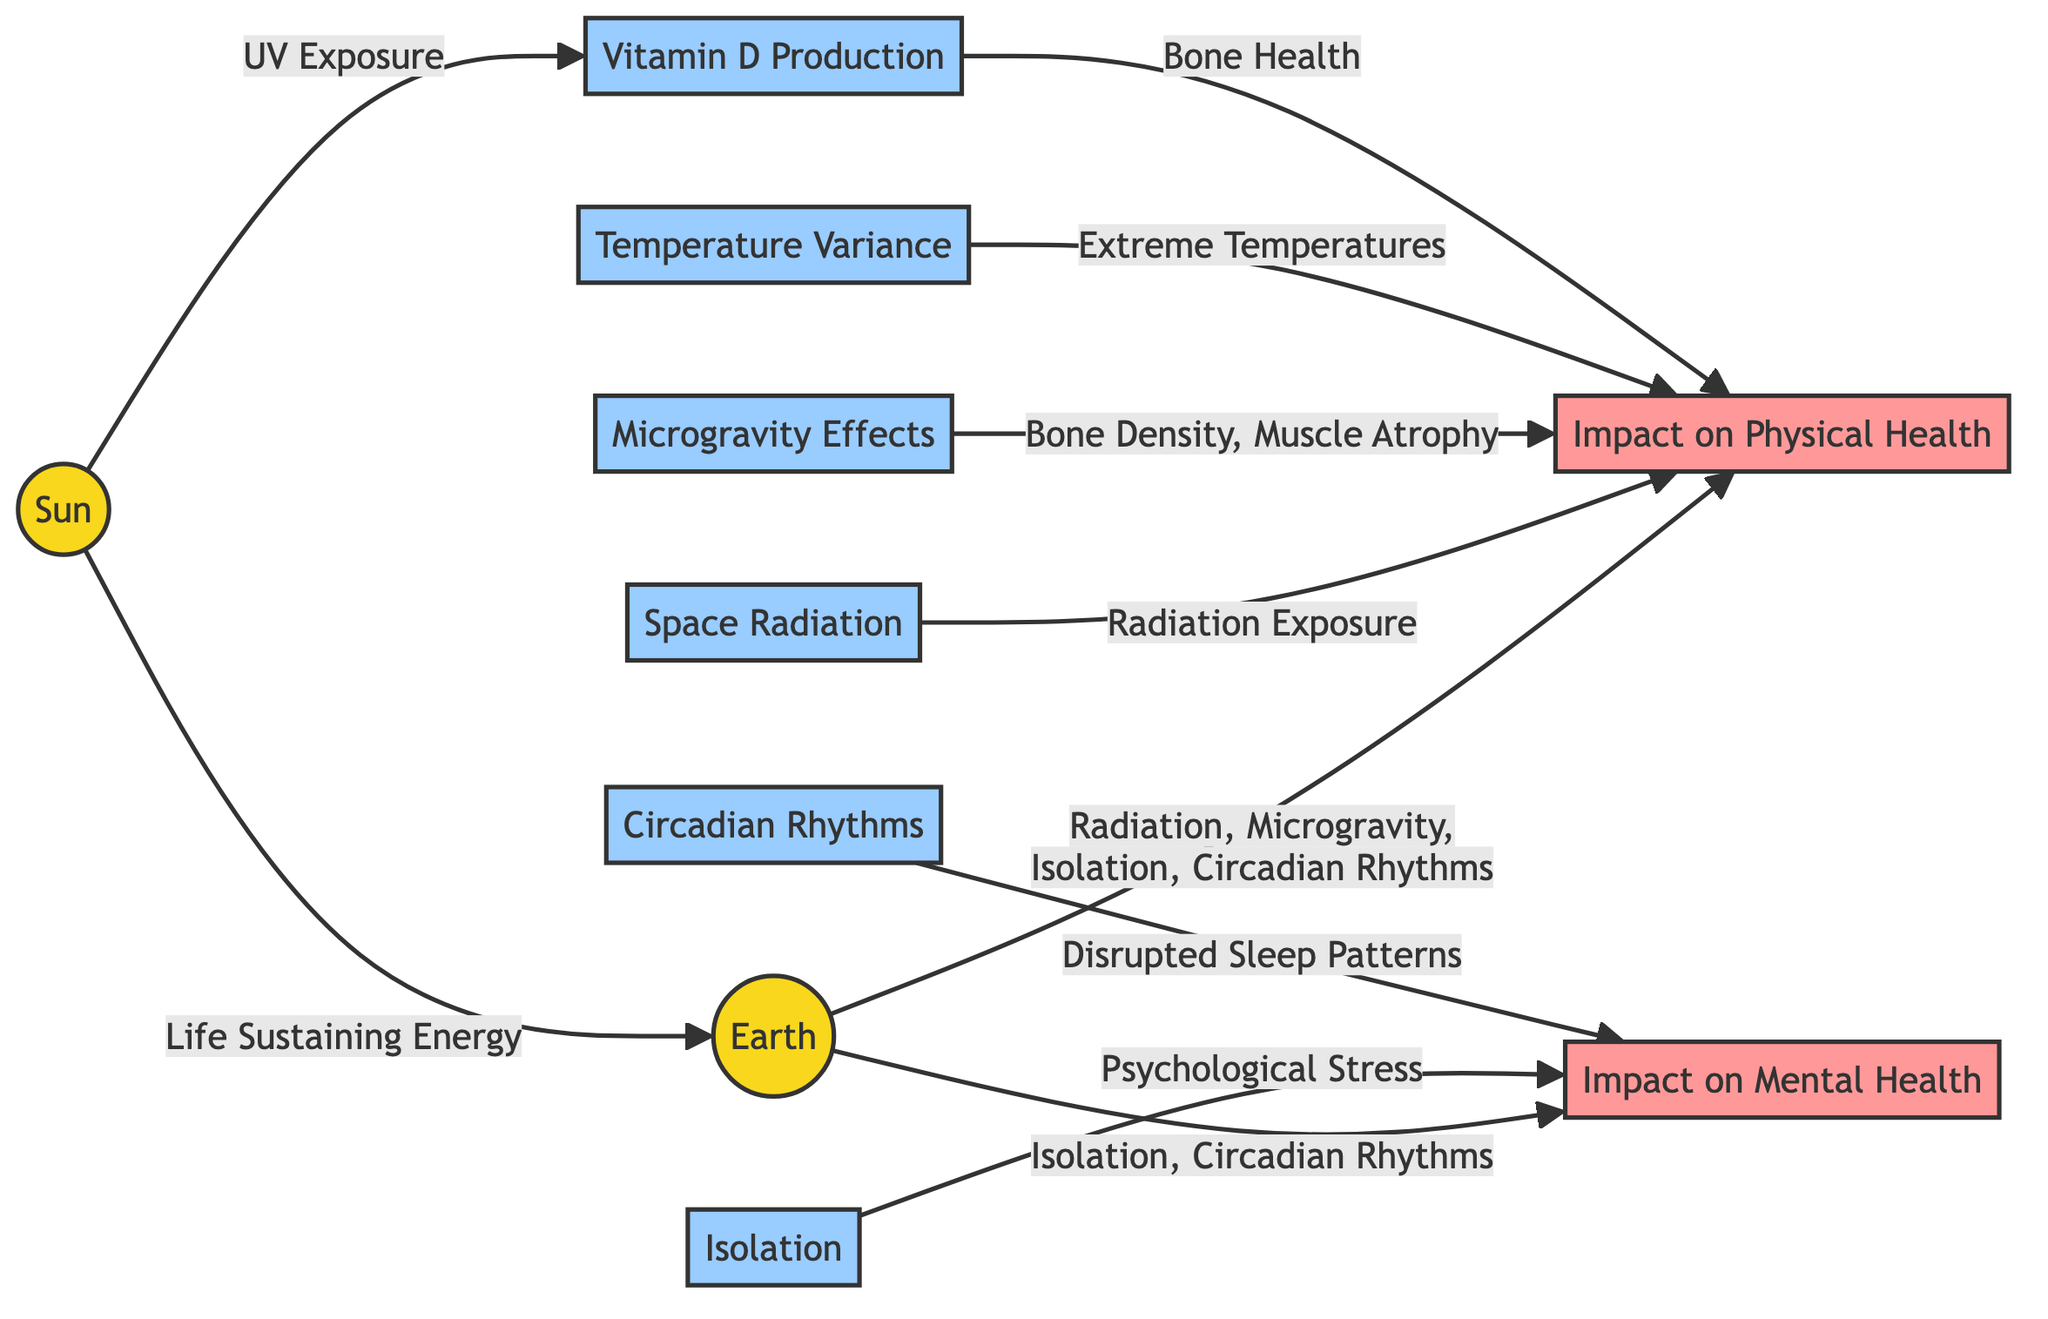What is connected to the Sun? The diagram shows that the Sun is connected to the Earth, indicating it provides life-sustaining energy.
Answer: Earth How many impacts on physical health are shown in the diagram? By counting the nodes connected to Impact on Physical Health, we see there are four factors listed: Space Radiation, Microgravity, Temperature, and Vitamin D.
Answer: 4 What causes the disruption of circadian rhythms? The diagram indicates that circadian rhythms are disrupted by isolation and are also connected to the Impact on Mental Health.
Answer: Isolation Which factor is linked to bone health? The diagram shows that Vitamin D is linked to bone health and connects to Impact on Physical Health.
Answer: Vitamin D How are microgravity effects described in terms of physical health? The diagram notes that microgravity leads to bone density loss and muscle atrophy, emphasizing its negative impact on physical health.
Answer: Bone Density, Muscle Atrophy What two impacts are specifically indicated for mental health? The diagram reveals that both isolation and disrupted circadian rhythms are related to mental health impacts.
Answer: Isolation, Circadian Rhythms Which health impact is associated with extreme temperatures? The diagram lists extreme temperatures as a factor impacting physical health, indicating it has adverse effects.
Answer: Impact on Physical Health How does the Sun contribute to physical health in terms of Vitamin D? The Sun provides UV exposure, which facilitates Vitamin D production, linking it directly to physical health through bone health.
Answer: Bone Health What connection is shown between Space Radiation and physical health? The diagram specifies that Space Radiation leads to radiation exposure, which negatively impacts physical health.
Answer: Radiation Exposure 